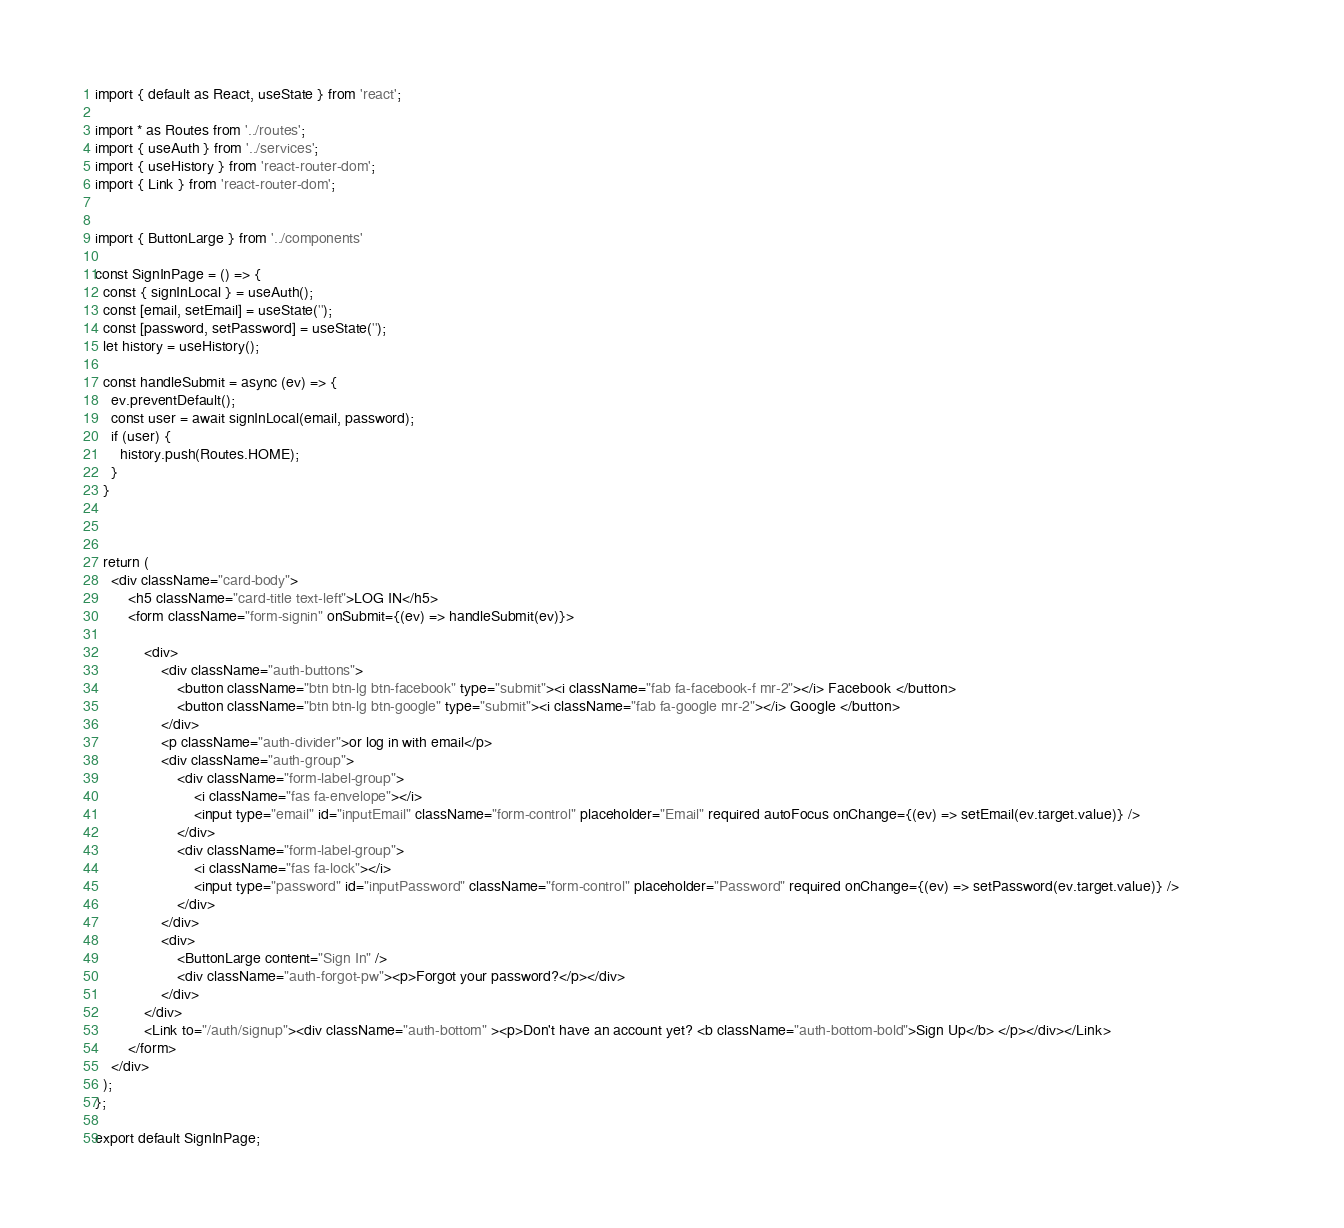Convert code to text. <code><loc_0><loc_0><loc_500><loc_500><_JavaScript_>import { default as React, useState } from 'react';

import * as Routes from '../routes';
import { useAuth } from '../services';
import { useHistory } from 'react-router-dom';
import { Link } from 'react-router-dom';


import { ButtonLarge } from '../components'

const SignInPage = () => {
  const { signInLocal } = useAuth();
  const [email, setEmail] = useState('');
  const [password, setPassword] = useState('');
  let history = useHistory();

  const handleSubmit = async (ev) => {
    ev.preventDefault();
    const user = await signInLocal(email, password);
    if (user) {
      history.push(Routes.HOME);
    }
  }



  return (
	<div className="card-body">
		<h5 className="card-title text-left">LOG IN</h5>
		<form className="form-signin" onSubmit={(ev) => handleSubmit(ev)}>

			<div>
				<div className="auth-buttons">
					<button className="btn btn-lg btn-facebook" type="submit"><i className="fab fa-facebook-f mr-2"></i> Facebook </button>
					<button className="btn btn-lg btn-google" type="submit"><i className="fab fa-google mr-2"></i> Google </button>
				</div>
				<p className="auth-divider">or log in with email</p>
				<div className="auth-group"> 
					<div className="form-label-group">
						<i className="fas fa-envelope"></i>
						<input type="email" id="inputEmail" className="form-control" placeholder="Email" required autoFocus onChange={(ev) => setEmail(ev.target.value)} />
					</div>
					<div className="form-label-group">
						<i className="fas fa-lock"></i>
						<input type="password" id="inputPassword" className="form-control" placeholder="Password" required onChange={(ev) => setPassword(ev.target.value)} />                    
					</div>
				</div>
				<div>
					<ButtonLarge content="Sign In" />
					<div className="auth-forgot-pw"><p>Forgot your password?</p></div>
				</div>
			</div>
			<Link to="/auth/signup"><div className="auth-bottom" ><p>Don't have an account yet? <b className="auth-bottom-bold">Sign Up</b> </p></div></Link>
		</form>
	</div>
  );
};

export default SignInPage;</code> 